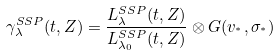Convert formula to latex. <formula><loc_0><loc_0><loc_500><loc_500>\gamma _ { \lambda } ^ { S S P } ( t , Z ) = \frac { L _ { \lambda } ^ { S S P } ( t , Z ) } { L _ { \lambda _ { 0 } } ^ { S S P } ( t , Z ) } \otimes G ( v _ { ^ { * } } , \sigma _ { ^ { * } } )</formula> 